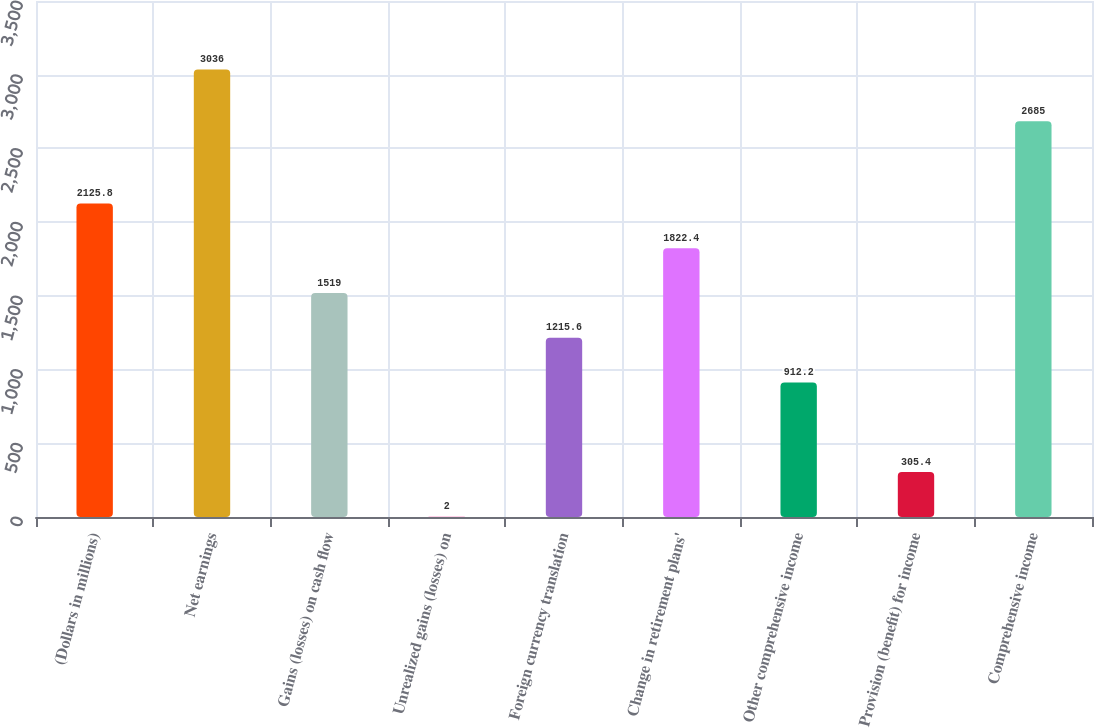Convert chart to OTSL. <chart><loc_0><loc_0><loc_500><loc_500><bar_chart><fcel>(Dollars in millions)<fcel>Net earnings<fcel>Gains (losses) on cash flow<fcel>Unrealized gains (losses) on<fcel>Foreign currency translation<fcel>Change in retirement plans'<fcel>Other comprehensive income<fcel>Provision (benefit) for income<fcel>Comprehensive income<nl><fcel>2125.8<fcel>3036<fcel>1519<fcel>2<fcel>1215.6<fcel>1822.4<fcel>912.2<fcel>305.4<fcel>2685<nl></chart> 